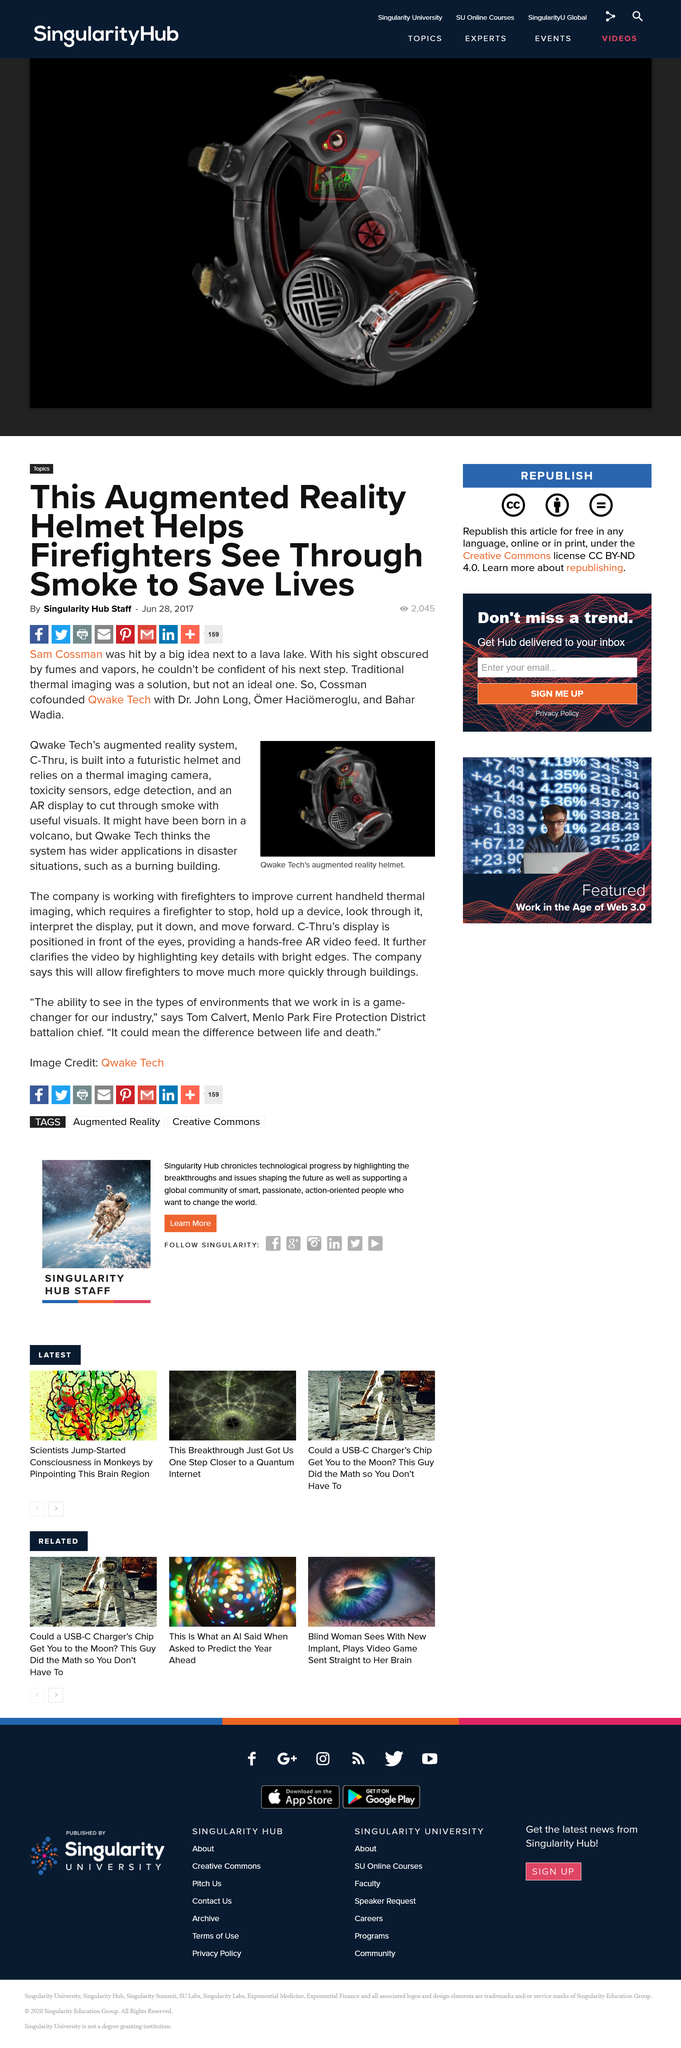Mention a couple of crucial points in this snapshot. The augmented reality system is referred to as C-Thru. It is estimated that 2,045 individuals viewed this article. Quake Techs AR system is a hands-free augmented reality technology. This article was published on June 28, 2017. Qwake Tech is collaborating with firefighters. 